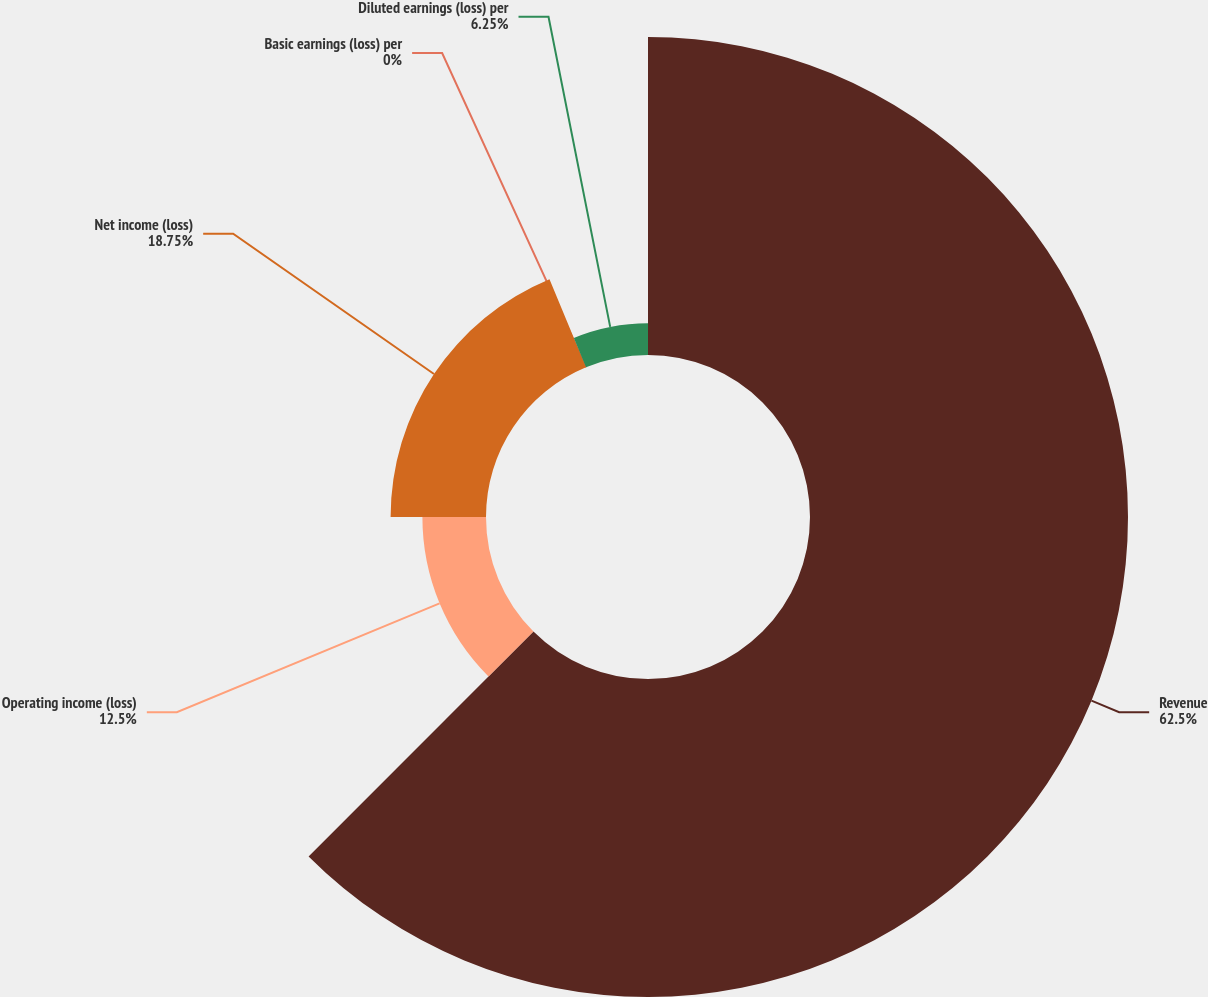Convert chart to OTSL. <chart><loc_0><loc_0><loc_500><loc_500><pie_chart><fcel>Revenue<fcel>Operating income (loss)<fcel>Net income (loss)<fcel>Basic earnings (loss) per<fcel>Diluted earnings (loss) per<nl><fcel>62.5%<fcel>12.5%<fcel>18.75%<fcel>0.0%<fcel>6.25%<nl></chart> 